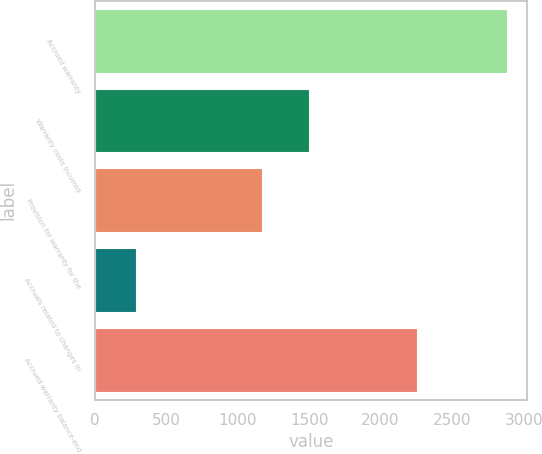<chart> <loc_0><loc_0><loc_500><loc_500><bar_chart><fcel>Accrued warranty<fcel>Warranty costs incurred<fcel>Provision for warranty for the<fcel>Accruals related to changes in<fcel>Accrued warranty balance-end<nl><fcel>2882<fcel>1502<fcel>1169<fcel>292<fcel>2257<nl></chart> 